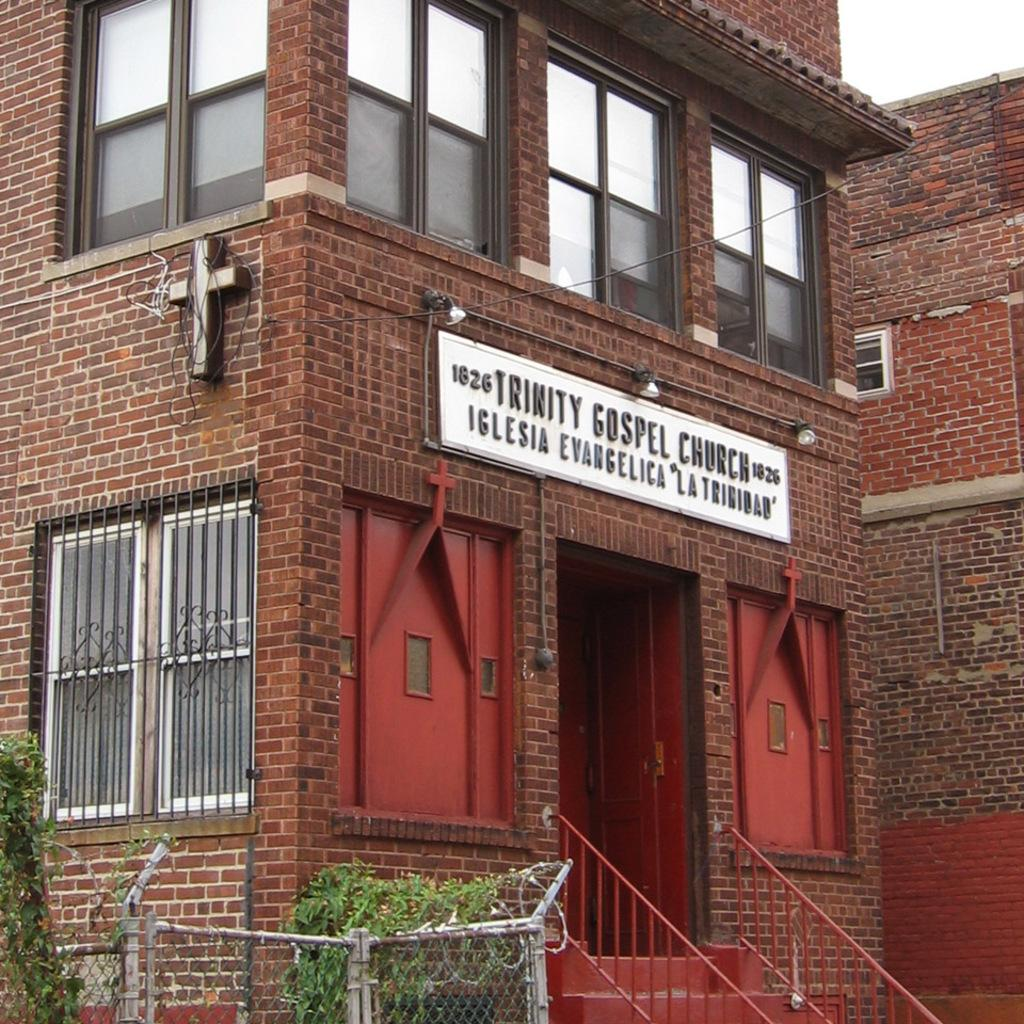What type of structures can be seen in the image? There are buildings in the image. What is the purpose of the name board in the image? The name board in the image is likely used for identification or direction. What type of vegetation is present in the image? There are plants in the image. What type of beef dish is being served in the image? There is no beef dish present in the image; it does not contain any food items. 